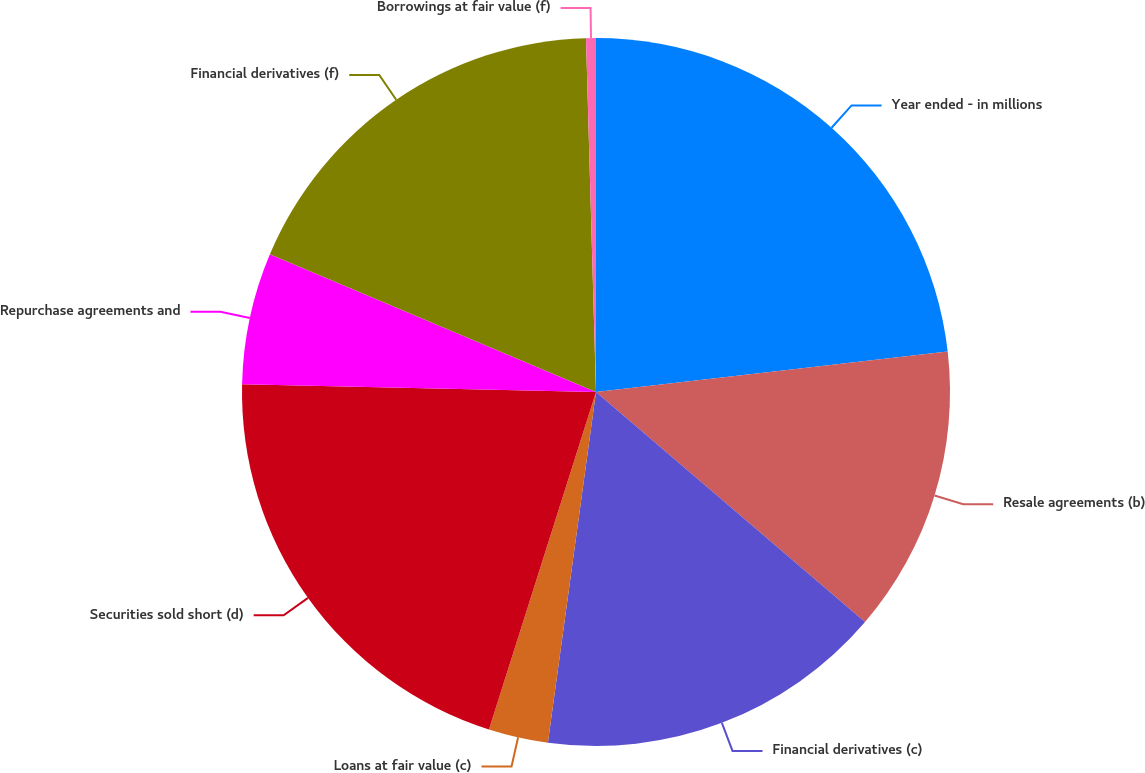<chart> <loc_0><loc_0><loc_500><loc_500><pie_chart><fcel>Year ended - in millions<fcel>Resale agreements (b)<fcel>Financial derivatives (c)<fcel>Loans at fair value (c)<fcel>Securities sold short (d)<fcel>Repurchase agreements and<fcel>Financial derivatives (f)<fcel>Borrowings at fair value (f)<nl><fcel>23.18%<fcel>13.08%<fcel>15.91%<fcel>2.72%<fcel>20.46%<fcel>6.01%<fcel>18.19%<fcel>0.45%<nl></chart> 